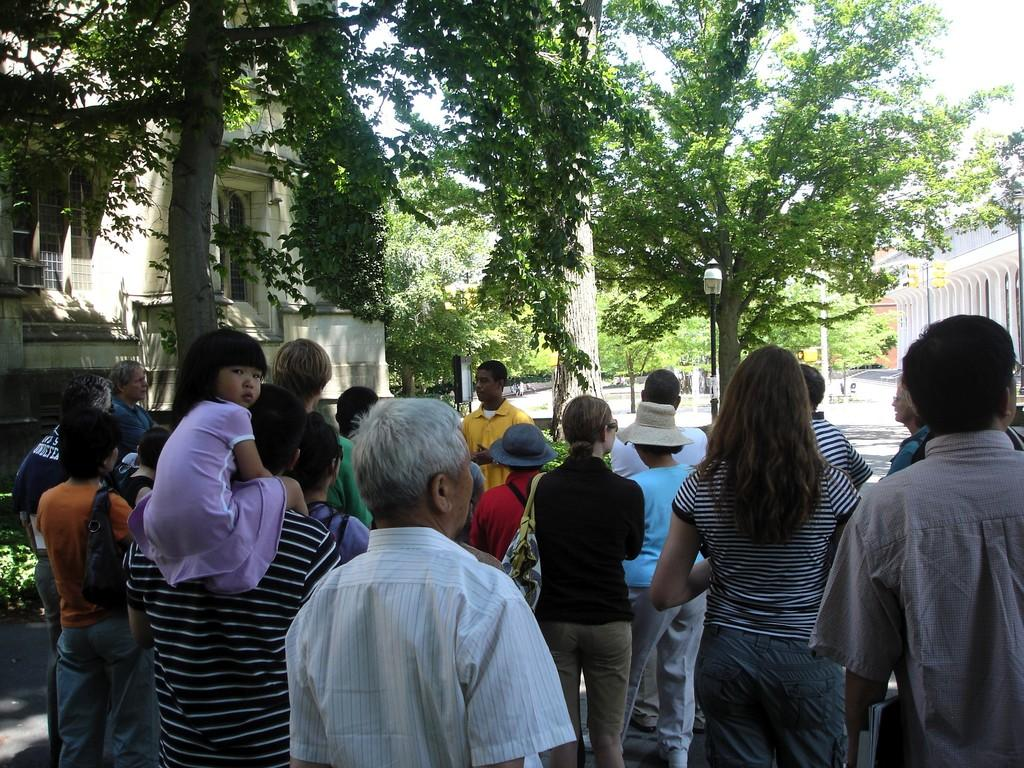What is happening in the image? There is a group of people standing in the image. What can be seen in the background of the image? There are trees, buildings, poles, and a walkway in the background of the image. What type of cherries are being picked by the people in the image? There are no cherries or any indication of picking in the image. 